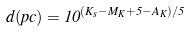Convert formula to latex. <formula><loc_0><loc_0><loc_500><loc_500>d ( p c ) = 1 0 ^ { ( K _ { s } - M _ { K } + 5 - A _ { K } ) / 5 }</formula> 